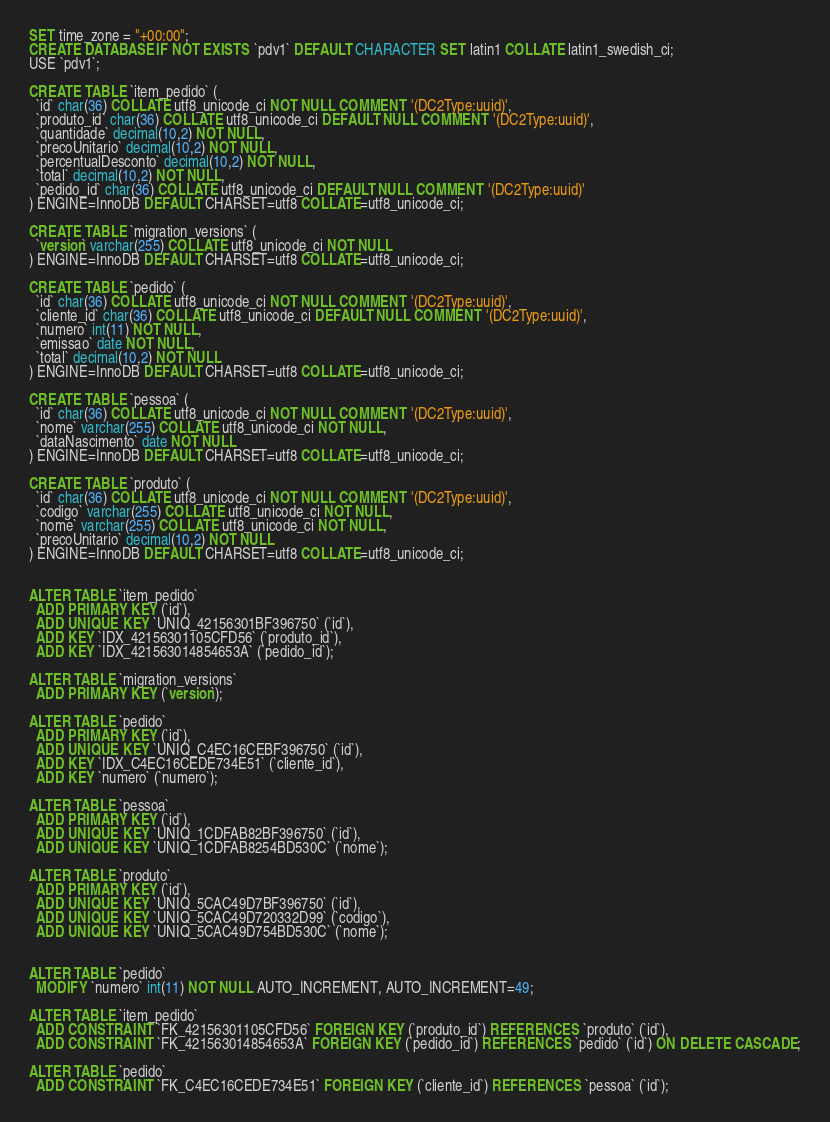<code> <loc_0><loc_0><loc_500><loc_500><_SQL_>SET time_zone = "+00:00";
CREATE DATABASE IF NOT EXISTS `pdv1` DEFAULT CHARACTER SET latin1 COLLATE latin1_swedish_ci;
USE `pdv1`;

CREATE TABLE `item_pedido` (
  `id` char(36) COLLATE utf8_unicode_ci NOT NULL COMMENT '(DC2Type:uuid)',
  `produto_id` char(36) COLLATE utf8_unicode_ci DEFAULT NULL COMMENT '(DC2Type:uuid)',
  `quantidade` decimal(10,2) NOT NULL,
  `precoUnitario` decimal(10,2) NOT NULL,
  `percentualDesconto` decimal(10,2) NOT NULL,
  `total` decimal(10,2) NOT NULL,
  `pedido_id` char(36) COLLATE utf8_unicode_ci DEFAULT NULL COMMENT '(DC2Type:uuid)'
) ENGINE=InnoDB DEFAULT CHARSET=utf8 COLLATE=utf8_unicode_ci;

CREATE TABLE `migration_versions` (
  `version` varchar(255) COLLATE utf8_unicode_ci NOT NULL
) ENGINE=InnoDB DEFAULT CHARSET=utf8 COLLATE=utf8_unicode_ci;

CREATE TABLE `pedido` (
  `id` char(36) COLLATE utf8_unicode_ci NOT NULL COMMENT '(DC2Type:uuid)',
  `cliente_id` char(36) COLLATE utf8_unicode_ci DEFAULT NULL COMMENT '(DC2Type:uuid)',
  `numero` int(11) NOT NULL,
  `emissao` date NOT NULL,
  `total` decimal(10,2) NOT NULL
) ENGINE=InnoDB DEFAULT CHARSET=utf8 COLLATE=utf8_unicode_ci;

CREATE TABLE `pessoa` (
  `id` char(36) COLLATE utf8_unicode_ci NOT NULL COMMENT '(DC2Type:uuid)',
  `nome` varchar(255) COLLATE utf8_unicode_ci NOT NULL,
  `dataNascimento` date NOT NULL
) ENGINE=InnoDB DEFAULT CHARSET=utf8 COLLATE=utf8_unicode_ci;

CREATE TABLE `produto` (
  `id` char(36) COLLATE utf8_unicode_ci NOT NULL COMMENT '(DC2Type:uuid)',
  `codigo` varchar(255) COLLATE utf8_unicode_ci NOT NULL,
  `nome` varchar(255) COLLATE utf8_unicode_ci NOT NULL,
  `precoUnitario` decimal(10,2) NOT NULL
) ENGINE=InnoDB DEFAULT CHARSET=utf8 COLLATE=utf8_unicode_ci;


ALTER TABLE `item_pedido`
  ADD PRIMARY KEY (`id`),
  ADD UNIQUE KEY `UNIQ_42156301BF396750` (`id`),
  ADD KEY `IDX_42156301105CFD56` (`produto_id`),
  ADD KEY `IDX_421563014854653A` (`pedido_id`);

ALTER TABLE `migration_versions`
  ADD PRIMARY KEY (`version`);

ALTER TABLE `pedido`
  ADD PRIMARY KEY (`id`),
  ADD UNIQUE KEY `UNIQ_C4EC16CEBF396750` (`id`),
  ADD KEY `IDX_C4EC16CEDE734E51` (`cliente_id`),
  ADD KEY `numero` (`numero`);

ALTER TABLE `pessoa`
  ADD PRIMARY KEY (`id`),
  ADD UNIQUE KEY `UNIQ_1CDFAB82BF396750` (`id`),
  ADD UNIQUE KEY `UNIQ_1CDFAB8254BD530C` (`nome`);

ALTER TABLE `produto`
  ADD PRIMARY KEY (`id`),
  ADD UNIQUE KEY `UNIQ_5CAC49D7BF396750` (`id`),
  ADD UNIQUE KEY `UNIQ_5CAC49D720332D99` (`codigo`),
  ADD UNIQUE KEY `UNIQ_5CAC49D754BD530C` (`nome`);


ALTER TABLE `pedido`
  MODIFY `numero` int(11) NOT NULL AUTO_INCREMENT, AUTO_INCREMENT=49;

ALTER TABLE `item_pedido`
  ADD CONSTRAINT `FK_42156301105CFD56` FOREIGN KEY (`produto_id`) REFERENCES `produto` (`id`),
  ADD CONSTRAINT `FK_421563014854653A` FOREIGN KEY (`pedido_id`) REFERENCES `pedido` (`id`) ON DELETE CASCADE;

ALTER TABLE `pedido`
  ADD CONSTRAINT `FK_C4EC16CEDE734E51` FOREIGN KEY (`cliente_id`) REFERENCES `pessoa` (`id`);
</code> 